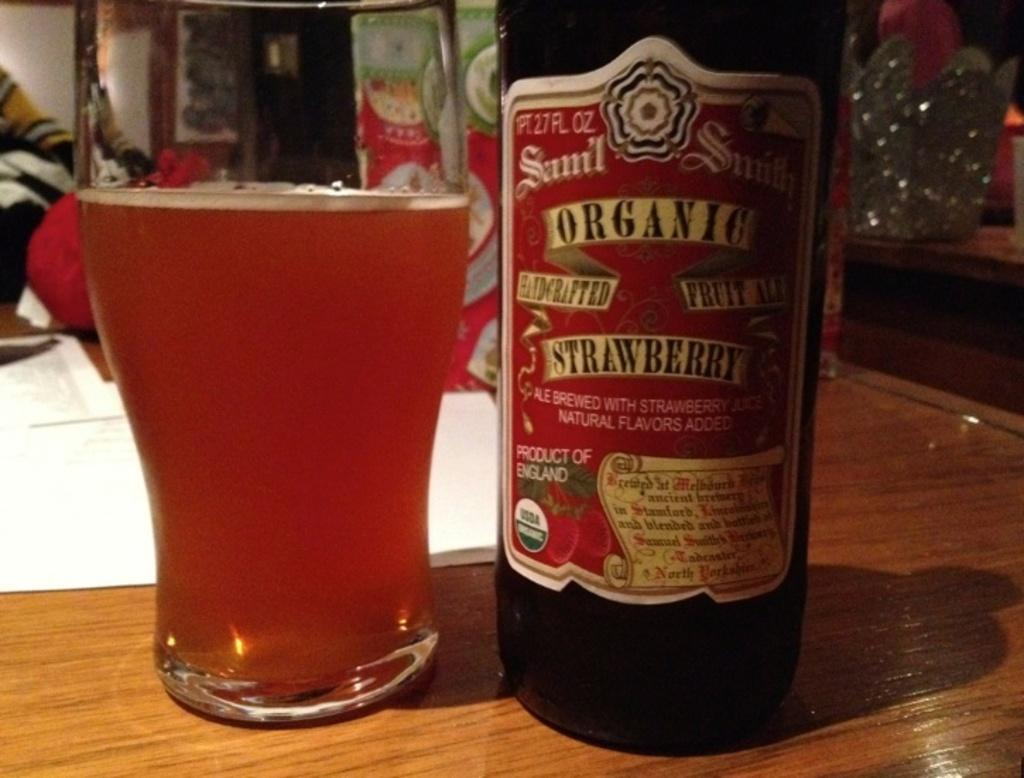<image>
Give a short and clear explanation of the subsequent image. An organic strawberry bottle of ale is poured into a glass. 